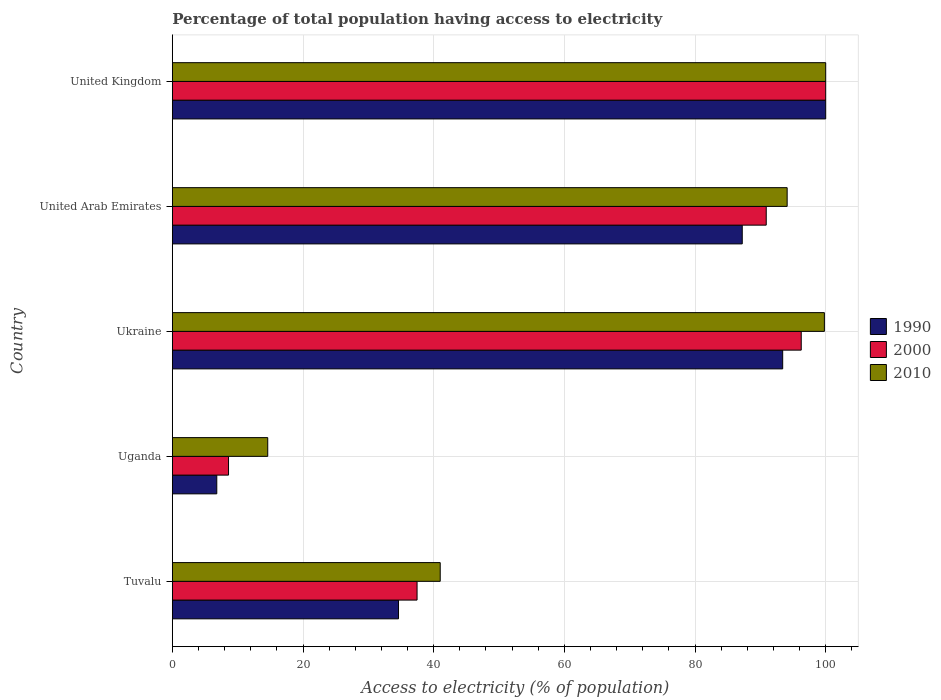How many different coloured bars are there?
Offer a terse response. 3. How many groups of bars are there?
Your response must be concise. 5. What is the label of the 3rd group of bars from the top?
Ensure brevity in your answer.  Ukraine. In how many cases, is the number of bars for a given country not equal to the number of legend labels?
Offer a very short reply. 0. What is the percentage of population that have access to electricity in 2000 in Tuvalu?
Offer a very short reply. 37.46. Across all countries, what is the maximum percentage of population that have access to electricity in 2000?
Make the answer very short. 100. Across all countries, what is the minimum percentage of population that have access to electricity in 2000?
Your answer should be very brief. 8.6. In which country was the percentage of population that have access to electricity in 2010 minimum?
Your answer should be compact. Uganda. What is the total percentage of population that have access to electricity in 2000 in the graph?
Keep it short and to the point. 333.21. What is the difference between the percentage of population that have access to electricity in 2010 in Tuvalu and that in Uganda?
Ensure brevity in your answer.  26.4. What is the difference between the percentage of population that have access to electricity in 2000 in Uganda and the percentage of population that have access to electricity in 2010 in United Kingdom?
Offer a terse response. -91.4. What is the average percentage of population that have access to electricity in 1990 per country?
Your answer should be very brief. 64.41. What is the difference between the percentage of population that have access to electricity in 2000 and percentage of population that have access to electricity in 2010 in Tuvalu?
Provide a succinct answer. -3.54. What is the ratio of the percentage of population that have access to electricity in 1990 in Uganda to that in United Arab Emirates?
Keep it short and to the point. 0.08. Is the difference between the percentage of population that have access to electricity in 2000 in Tuvalu and Ukraine greater than the difference between the percentage of population that have access to electricity in 2010 in Tuvalu and Ukraine?
Your answer should be very brief. No. What is the difference between the highest and the second highest percentage of population that have access to electricity in 1990?
Your answer should be very brief. 6.58. What is the difference between the highest and the lowest percentage of population that have access to electricity in 1990?
Offer a terse response. 93.2. Is the sum of the percentage of population that have access to electricity in 2000 in Tuvalu and United Kingdom greater than the maximum percentage of population that have access to electricity in 1990 across all countries?
Make the answer very short. Yes. Is it the case that in every country, the sum of the percentage of population that have access to electricity in 2000 and percentage of population that have access to electricity in 1990 is greater than the percentage of population that have access to electricity in 2010?
Offer a very short reply. Yes. How many bars are there?
Make the answer very short. 15. How many countries are there in the graph?
Your answer should be compact. 5. Are the values on the major ticks of X-axis written in scientific E-notation?
Your response must be concise. No. Does the graph contain any zero values?
Make the answer very short. No. Does the graph contain grids?
Your answer should be compact. Yes. What is the title of the graph?
Ensure brevity in your answer.  Percentage of total population having access to electricity. Does "2004" appear as one of the legend labels in the graph?
Your answer should be compact. No. What is the label or title of the X-axis?
Provide a short and direct response. Access to electricity (% of population). What is the Access to electricity (% of population) in 1990 in Tuvalu?
Provide a short and direct response. 34.62. What is the Access to electricity (% of population) of 2000 in Tuvalu?
Your answer should be very brief. 37.46. What is the Access to electricity (% of population) of 1990 in Uganda?
Give a very brief answer. 6.8. What is the Access to electricity (% of population) in 2000 in Uganda?
Make the answer very short. 8.6. What is the Access to electricity (% of population) in 1990 in Ukraine?
Your response must be concise. 93.42. What is the Access to electricity (% of population) in 2000 in Ukraine?
Your answer should be very brief. 96.26. What is the Access to electricity (% of population) in 2010 in Ukraine?
Give a very brief answer. 99.8. What is the Access to electricity (% of population) in 1990 in United Arab Emirates?
Your response must be concise. 87.23. What is the Access to electricity (% of population) of 2000 in United Arab Emirates?
Your answer should be compact. 90.9. What is the Access to electricity (% of population) of 2010 in United Arab Emirates?
Your answer should be compact. 94.1. What is the Access to electricity (% of population) in 1990 in United Kingdom?
Your answer should be compact. 100. What is the Access to electricity (% of population) in 2000 in United Kingdom?
Make the answer very short. 100. What is the Access to electricity (% of population) of 2010 in United Kingdom?
Your answer should be compact. 100. Across all countries, what is the maximum Access to electricity (% of population) of 1990?
Provide a succinct answer. 100. Across all countries, what is the maximum Access to electricity (% of population) of 2000?
Ensure brevity in your answer.  100. Across all countries, what is the maximum Access to electricity (% of population) of 2010?
Your response must be concise. 100. Across all countries, what is the minimum Access to electricity (% of population) in 1990?
Provide a short and direct response. 6.8. Across all countries, what is the minimum Access to electricity (% of population) of 2010?
Offer a very short reply. 14.6. What is the total Access to electricity (% of population) in 1990 in the graph?
Your answer should be very brief. 322.06. What is the total Access to electricity (% of population) in 2000 in the graph?
Make the answer very short. 333.21. What is the total Access to electricity (% of population) in 2010 in the graph?
Your answer should be very brief. 349.5. What is the difference between the Access to electricity (% of population) in 1990 in Tuvalu and that in Uganda?
Your answer should be compact. 27.82. What is the difference between the Access to electricity (% of population) of 2000 in Tuvalu and that in Uganda?
Make the answer very short. 28.86. What is the difference between the Access to electricity (% of population) of 2010 in Tuvalu and that in Uganda?
Your answer should be very brief. 26.4. What is the difference between the Access to electricity (% of population) in 1990 in Tuvalu and that in Ukraine?
Your answer should be very brief. -58.8. What is the difference between the Access to electricity (% of population) of 2000 in Tuvalu and that in Ukraine?
Make the answer very short. -58.8. What is the difference between the Access to electricity (% of population) of 2010 in Tuvalu and that in Ukraine?
Give a very brief answer. -58.8. What is the difference between the Access to electricity (% of population) of 1990 in Tuvalu and that in United Arab Emirates?
Make the answer very short. -52.61. What is the difference between the Access to electricity (% of population) in 2000 in Tuvalu and that in United Arab Emirates?
Provide a short and direct response. -53.44. What is the difference between the Access to electricity (% of population) in 2010 in Tuvalu and that in United Arab Emirates?
Offer a terse response. -53.1. What is the difference between the Access to electricity (% of population) of 1990 in Tuvalu and that in United Kingdom?
Your response must be concise. -65.38. What is the difference between the Access to electricity (% of population) of 2000 in Tuvalu and that in United Kingdom?
Offer a very short reply. -62.54. What is the difference between the Access to electricity (% of population) in 2010 in Tuvalu and that in United Kingdom?
Provide a short and direct response. -59. What is the difference between the Access to electricity (% of population) in 1990 in Uganda and that in Ukraine?
Your answer should be very brief. -86.62. What is the difference between the Access to electricity (% of population) of 2000 in Uganda and that in Ukraine?
Give a very brief answer. -87.66. What is the difference between the Access to electricity (% of population) of 2010 in Uganda and that in Ukraine?
Keep it short and to the point. -85.2. What is the difference between the Access to electricity (% of population) of 1990 in Uganda and that in United Arab Emirates?
Ensure brevity in your answer.  -80.43. What is the difference between the Access to electricity (% of population) in 2000 in Uganda and that in United Arab Emirates?
Provide a succinct answer. -82.3. What is the difference between the Access to electricity (% of population) of 2010 in Uganda and that in United Arab Emirates?
Provide a short and direct response. -79.5. What is the difference between the Access to electricity (% of population) in 1990 in Uganda and that in United Kingdom?
Offer a very short reply. -93.2. What is the difference between the Access to electricity (% of population) in 2000 in Uganda and that in United Kingdom?
Give a very brief answer. -91.4. What is the difference between the Access to electricity (% of population) of 2010 in Uganda and that in United Kingdom?
Keep it short and to the point. -85.4. What is the difference between the Access to electricity (% of population) of 1990 in Ukraine and that in United Arab Emirates?
Give a very brief answer. 6.19. What is the difference between the Access to electricity (% of population) in 2000 in Ukraine and that in United Arab Emirates?
Offer a very short reply. 5.36. What is the difference between the Access to electricity (% of population) in 2010 in Ukraine and that in United Arab Emirates?
Provide a succinct answer. 5.7. What is the difference between the Access to electricity (% of population) of 1990 in Ukraine and that in United Kingdom?
Your response must be concise. -6.58. What is the difference between the Access to electricity (% of population) in 2000 in Ukraine and that in United Kingdom?
Offer a very short reply. -3.74. What is the difference between the Access to electricity (% of population) of 2010 in Ukraine and that in United Kingdom?
Keep it short and to the point. -0.2. What is the difference between the Access to electricity (% of population) of 1990 in United Arab Emirates and that in United Kingdom?
Ensure brevity in your answer.  -12.77. What is the difference between the Access to electricity (% of population) of 2000 in United Arab Emirates and that in United Kingdom?
Provide a short and direct response. -9.1. What is the difference between the Access to electricity (% of population) in 1990 in Tuvalu and the Access to electricity (% of population) in 2000 in Uganda?
Your answer should be compact. 26.02. What is the difference between the Access to electricity (% of population) in 1990 in Tuvalu and the Access to electricity (% of population) in 2010 in Uganda?
Ensure brevity in your answer.  20.02. What is the difference between the Access to electricity (% of population) of 2000 in Tuvalu and the Access to electricity (% of population) of 2010 in Uganda?
Your response must be concise. 22.86. What is the difference between the Access to electricity (% of population) of 1990 in Tuvalu and the Access to electricity (% of population) of 2000 in Ukraine?
Offer a very short reply. -61.64. What is the difference between the Access to electricity (% of population) of 1990 in Tuvalu and the Access to electricity (% of population) of 2010 in Ukraine?
Your answer should be compact. -65.18. What is the difference between the Access to electricity (% of population) of 2000 in Tuvalu and the Access to electricity (% of population) of 2010 in Ukraine?
Make the answer very short. -62.34. What is the difference between the Access to electricity (% of population) of 1990 in Tuvalu and the Access to electricity (% of population) of 2000 in United Arab Emirates?
Your response must be concise. -56.28. What is the difference between the Access to electricity (% of population) of 1990 in Tuvalu and the Access to electricity (% of population) of 2010 in United Arab Emirates?
Ensure brevity in your answer.  -59.48. What is the difference between the Access to electricity (% of population) in 2000 in Tuvalu and the Access to electricity (% of population) in 2010 in United Arab Emirates?
Your answer should be compact. -56.64. What is the difference between the Access to electricity (% of population) in 1990 in Tuvalu and the Access to electricity (% of population) in 2000 in United Kingdom?
Your answer should be compact. -65.38. What is the difference between the Access to electricity (% of population) of 1990 in Tuvalu and the Access to electricity (% of population) of 2010 in United Kingdom?
Provide a succinct answer. -65.38. What is the difference between the Access to electricity (% of population) in 2000 in Tuvalu and the Access to electricity (% of population) in 2010 in United Kingdom?
Ensure brevity in your answer.  -62.54. What is the difference between the Access to electricity (% of population) of 1990 in Uganda and the Access to electricity (% of population) of 2000 in Ukraine?
Your answer should be very brief. -89.46. What is the difference between the Access to electricity (% of population) in 1990 in Uganda and the Access to electricity (% of population) in 2010 in Ukraine?
Your answer should be very brief. -93. What is the difference between the Access to electricity (% of population) in 2000 in Uganda and the Access to electricity (% of population) in 2010 in Ukraine?
Ensure brevity in your answer.  -91.2. What is the difference between the Access to electricity (% of population) in 1990 in Uganda and the Access to electricity (% of population) in 2000 in United Arab Emirates?
Offer a terse response. -84.1. What is the difference between the Access to electricity (% of population) in 1990 in Uganda and the Access to electricity (% of population) in 2010 in United Arab Emirates?
Your answer should be compact. -87.3. What is the difference between the Access to electricity (% of population) of 2000 in Uganda and the Access to electricity (% of population) of 2010 in United Arab Emirates?
Give a very brief answer. -85.5. What is the difference between the Access to electricity (% of population) of 1990 in Uganda and the Access to electricity (% of population) of 2000 in United Kingdom?
Your answer should be very brief. -93.2. What is the difference between the Access to electricity (% of population) of 1990 in Uganda and the Access to electricity (% of population) of 2010 in United Kingdom?
Your answer should be compact. -93.2. What is the difference between the Access to electricity (% of population) in 2000 in Uganda and the Access to electricity (% of population) in 2010 in United Kingdom?
Ensure brevity in your answer.  -91.4. What is the difference between the Access to electricity (% of population) in 1990 in Ukraine and the Access to electricity (% of population) in 2000 in United Arab Emirates?
Offer a very short reply. 2.52. What is the difference between the Access to electricity (% of population) of 1990 in Ukraine and the Access to electricity (% of population) of 2010 in United Arab Emirates?
Provide a short and direct response. -0.68. What is the difference between the Access to electricity (% of population) of 2000 in Ukraine and the Access to electricity (% of population) of 2010 in United Arab Emirates?
Keep it short and to the point. 2.16. What is the difference between the Access to electricity (% of population) of 1990 in Ukraine and the Access to electricity (% of population) of 2000 in United Kingdom?
Your response must be concise. -6.58. What is the difference between the Access to electricity (% of population) in 1990 in Ukraine and the Access to electricity (% of population) in 2010 in United Kingdom?
Offer a terse response. -6.58. What is the difference between the Access to electricity (% of population) in 2000 in Ukraine and the Access to electricity (% of population) in 2010 in United Kingdom?
Offer a terse response. -3.74. What is the difference between the Access to electricity (% of population) in 1990 in United Arab Emirates and the Access to electricity (% of population) in 2000 in United Kingdom?
Keep it short and to the point. -12.77. What is the difference between the Access to electricity (% of population) of 1990 in United Arab Emirates and the Access to electricity (% of population) of 2010 in United Kingdom?
Give a very brief answer. -12.77. What is the difference between the Access to electricity (% of population) of 2000 in United Arab Emirates and the Access to electricity (% of population) of 2010 in United Kingdom?
Your answer should be very brief. -9.1. What is the average Access to electricity (% of population) in 1990 per country?
Your answer should be compact. 64.41. What is the average Access to electricity (% of population) in 2000 per country?
Offer a very short reply. 66.64. What is the average Access to electricity (% of population) in 2010 per country?
Give a very brief answer. 69.9. What is the difference between the Access to electricity (% of population) of 1990 and Access to electricity (% of population) of 2000 in Tuvalu?
Your answer should be very brief. -2.84. What is the difference between the Access to electricity (% of population) in 1990 and Access to electricity (% of population) in 2010 in Tuvalu?
Your answer should be very brief. -6.38. What is the difference between the Access to electricity (% of population) in 2000 and Access to electricity (% of population) in 2010 in Tuvalu?
Provide a short and direct response. -3.54. What is the difference between the Access to electricity (% of population) in 1990 and Access to electricity (% of population) in 2000 in Uganda?
Give a very brief answer. -1.8. What is the difference between the Access to electricity (% of population) in 2000 and Access to electricity (% of population) in 2010 in Uganda?
Give a very brief answer. -6. What is the difference between the Access to electricity (% of population) in 1990 and Access to electricity (% of population) in 2000 in Ukraine?
Provide a short and direct response. -2.84. What is the difference between the Access to electricity (% of population) of 1990 and Access to electricity (% of population) of 2010 in Ukraine?
Your answer should be very brief. -6.38. What is the difference between the Access to electricity (% of population) in 2000 and Access to electricity (% of population) in 2010 in Ukraine?
Ensure brevity in your answer.  -3.54. What is the difference between the Access to electricity (% of population) of 1990 and Access to electricity (% of population) of 2000 in United Arab Emirates?
Give a very brief answer. -3.67. What is the difference between the Access to electricity (% of population) in 1990 and Access to electricity (% of population) in 2010 in United Arab Emirates?
Give a very brief answer. -6.87. What is the difference between the Access to electricity (% of population) of 2000 and Access to electricity (% of population) of 2010 in United Arab Emirates?
Your answer should be compact. -3.2. What is the difference between the Access to electricity (% of population) in 1990 and Access to electricity (% of population) in 2000 in United Kingdom?
Offer a very short reply. 0. What is the difference between the Access to electricity (% of population) in 2000 and Access to electricity (% of population) in 2010 in United Kingdom?
Provide a short and direct response. 0. What is the ratio of the Access to electricity (% of population) of 1990 in Tuvalu to that in Uganda?
Ensure brevity in your answer.  5.09. What is the ratio of the Access to electricity (% of population) of 2000 in Tuvalu to that in Uganda?
Keep it short and to the point. 4.36. What is the ratio of the Access to electricity (% of population) of 2010 in Tuvalu to that in Uganda?
Make the answer very short. 2.81. What is the ratio of the Access to electricity (% of population) of 1990 in Tuvalu to that in Ukraine?
Your response must be concise. 0.37. What is the ratio of the Access to electricity (% of population) in 2000 in Tuvalu to that in Ukraine?
Your answer should be very brief. 0.39. What is the ratio of the Access to electricity (% of population) of 2010 in Tuvalu to that in Ukraine?
Make the answer very short. 0.41. What is the ratio of the Access to electricity (% of population) in 1990 in Tuvalu to that in United Arab Emirates?
Make the answer very short. 0.4. What is the ratio of the Access to electricity (% of population) in 2000 in Tuvalu to that in United Arab Emirates?
Offer a very short reply. 0.41. What is the ratio of the Access to electricity (% of population) of 2010 in Tuvalu to that in United Arab Emirates?
Your response must be concise. 0.44. What is the ratio of the Access to electricity (% of population) in 1990 in Tuvalu to that in United Kingdom?
Make the answer very short. 0.35. What is the ratio of the Access to electricity (% of population) in 2000 in Tuvalu to that in United Kingdom?
Offer a very short reply. 0.37. What is the ratio of the Access to electricity (% of population) in 2010 in Tuvalu to that in United Kingdom?
Your response must be concise. 0.41. What is the ratio of the Access to electricity (% of population) of 1990 in Uganda to that in Ukraine?
Make the answer very short. 0.07. What is the ratio of the Access to electricity (% of population) of 2000 in Uganda to that in Ukraine?
Make the answer very short. 0.09. What is the ratio of the Access to electricity (% of population) in 2010 in Uganda to that in Ukraine?
Ensure brevity in your answer.  0.15. What is the ratio of the Access to electricity (% of population) of 1990 in Uganda to that in United Arab Emirates?
Ensure brevity in your answer.  0.08. What is the ratio of the Access to electricity (% of population) of 2000 in Uganda to that in United Arab Emirates?
Offer a terse response. 0.09. What is the ratio of the Access to electricity (% of population) in 2010 in Uganda to that in United Arab Emirates?
Make the answer very short. 0.16. What is the ratio of the Access to electricity (% of population) in 1990 in Uganda to that in United Kingdom?
Your answer should be very brief. 0.07. What is the ratio of the Access to electricity (% of population) in 2000 in Uganda to that in United Kingdom?
Your answer should be very brief. 0.09. What is the ratio of the Access to electricity (% of population) in 2010 in Uganda to that in United Kingdom?
Your response must be concise. 0.15. What is the ratio of the Access to electricity (% of population) of 1990 in Ukraine to that in United Arab Emirates?
Your response must be concise. 1.07. What is the ratio of the Access to electricity (% of population) of 2000 in Ukraine to that in United Arab Emirates?
Provide a short and direct response. 1.06. What is the ratio of the Access to electricity (% of population) of 2010 in Ukraine to that in United Arab Emirates?
Keep it short and to the point. 1.06. What is the ratio of the Access to electricity (% of population) of 1990 in Ukraine to that in United Kingdom?
Offer a terse response. 0.93. What is the ratio of the Access to electricity (% of population) of 2000 in Ukraine to that in United Kingdom?
Provide a succinct answer. 0.96. What is the ratio of the Access to electricity (% of population) of 1990 in United Arab Emirates to that in United Kingdom?
Offer a terse response. 0.87. What is the ratio of the Access to electricity (% of population) of 2000 in United Arab Emirates to that in United Kingdom?
Your answer should be compact. 0.91. What is the ratio of the Access to electricity (% of population) of 2010 in United Arab Emirates to that in United Kingdom?
Provide a succinct answer. 0.94. What is the difference between the highest and the second highest Access to electricity (% of population) of 1990?
Your answer should be very brief. 6.58. What is the difference between the highest and the second highest Access to electricity (% of population) of 2000?
Make the answer very short. 3.74. What is the difference between the highest and the lowest Access to electricity (% of population) in 1990?
Provide a short and direct response. 93.2. What is the difference between the highest and the lowest Access to electricity (% of population) of 2000?
Offer a terse response. 91.4. What is the difference between the highest and the lowest Access to electricity (% of population) in 2010?
Ensure brevity in your answer.  85.4. 